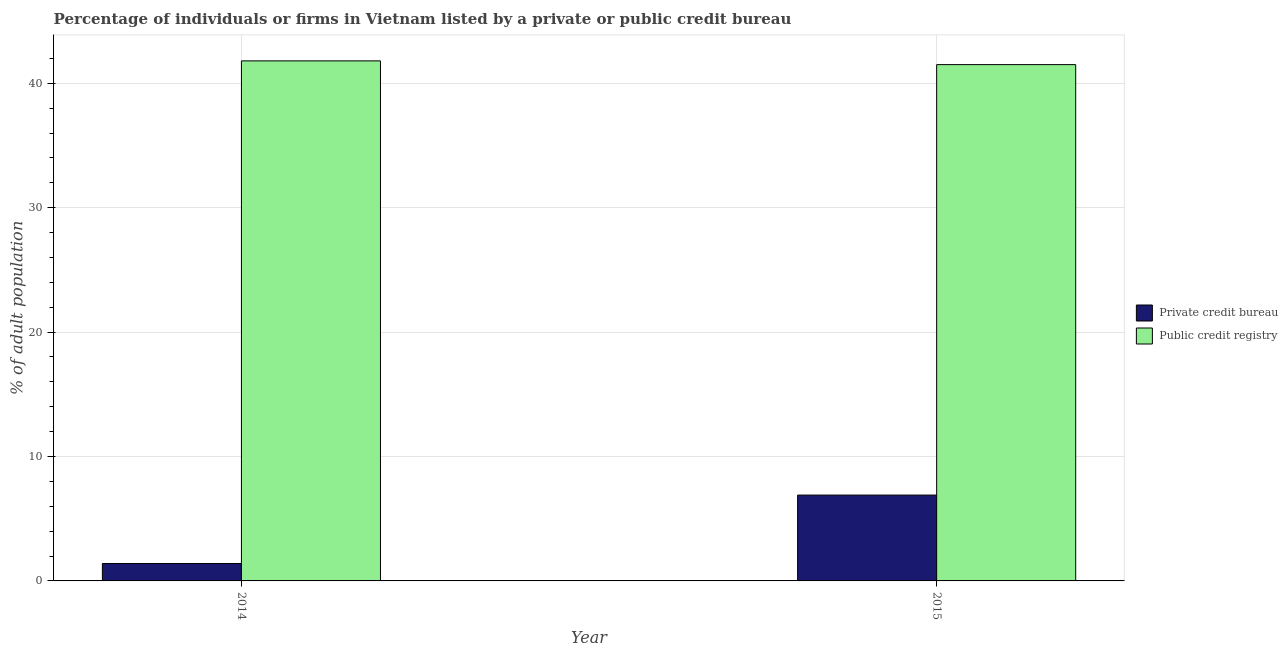How many groups of bars are there?
Offer a terse response. 2. Are the number of bars per tick equal to the number of legend labels?
Your response must be concise. Yes. Are the number of bars on each tick of the X-axis equal?
Your response must be concise. Yes. What is the label of the 2nd group of bars from the left?
Your response must be concise. 2015. What is the percentage of firms listed by private credit bureau in 2015?
Keep it short and to the point. 6.9. Across all years, what is the maximum percentage of firms listed by public credit bureau?
Offer a terse response. 41.8. Across all years, what is the minimum percentage of firms listed by public credit bureau?
Your answer should be compact. 41.5. What is the total percentage of firms listed by public credit bureau in the graph?
Your response must be concise. 83.3. What is the difference between the percentage of firms listed by private credit bureau in 2014 and that in 2015?
Offer a terse response. -5.5. What is the average percentage of firms listed by private credit bureau per year?
Keep it short and to the point. 4.15. In how many years, is the percentage of firms listed by private credit bureau greater than 40 %?
Your answer should be compact. 0. What is the ratio of the percentage of firms listed by private credit bureau in 2014 to that in 2015?
Give a very brief answer. 0.2. Is the percentage of firms listed by private credit bureau in 2014 less than that in 2015?
Keep it short and to the point. Yes. What does the 2nd bar from the left in 2014 represents?
Make the answer very short. Public credit registry. What does the 2nd bar from the right in 2015 represents?
Make the answer very short. Private credit bureau. How many bars are there?
Give a very brief answer. 4. Are all the bars in the graph horizontal?
Offer a terse response. No. What is the difference between two consecutive major ticks on the Y-axis?
Your response must be concise. 10. Are the values on the major ticks of Y-axis written in scientific E-notation?
Keep it short and to the point. No. Where does the legend appear in the graph?
Provide a short and direct response. Center right. How many legend labels are there?
Ensure brevity in your answer.  2. What is the title of the graph?
Give a very brief answer. Percentage of individuals or firms in Vietnam listed by a private or public credit bureau. Does "Lower secondary education" appear as one of the legend labels in the graph?
Provide a succinct answer. No. What is the label or title of the Y-axis?
Make the answer very short. % of adult population. What is the % of adult population in Private credit bureau in 2014?
Provide a short and direct response. 1.4. What is the % of adult population of Public credit registry in 2014?
Your answer should be very brief. 41.8. What is the % of adult population in Public credit registry in 2015?
Provide a short and direct response. 41.5. Across all years, what is the maximum % of adult population of Private credit bureau?
Offer a terse response. 6.9. Across all years, what is the maximum % of adult population of Public credit registry?
Your answer should be compact. 41.8. Across all years, what is the minimum % of adult population in Private credit bureau?
Your answer should be very brief. 1.4. Across all years, what is the minimum % of adult population of Public credit registry?
Ensure brevity in your answer.  41.5. What is the total % of adult population in Private credit bureau in the graph?
Your answer should be very brief. 8.3. What is the total % of adult population of Public credit registry in the graph?
Your response must be concise. 83.3. What is the difference between the % of adult population of Public credit registry in 2014 and that in 2015?
Offer a very short reply. 0.3. What is the difference between the % of adult population in Private credit bureau in 2014 and the % of adult population in Public credit registry in 2015?
Your response must be concise. -40.1. What is the average % of adult population in Private credit bureau per year?
Offer a very short reply. 4.15. What is the average % of adult population in Public credit registry per year?
Ensure brevity in your answer.  41.65. In the year 2014, what is the difference between the % of adult population in Private credit bureau and % of adult population in Public credit registry?
Give a very brief answer. -40.4. In the year 2015, what is the difference between the % of adult population in Private credit bureau and % of adult population in Public credit registry?
Provide a succinct answer. -34.6. What is the ratio of the % of adult population of Private credit bureau in 2014 to that in 2015?
Keep it short and to the point. 0.2. What is the difference between the highest and the second highest % of adult population of Private credit bureau?
Your answer should be compact. 5.5. What is the difference between the highest and the lowest % of adult population in Public credit registry?
Your answer should be compact. 0.3. 